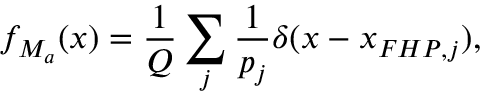Convert formula to latex. <formula><loc_0><loc_0><loc_500><loc_500>f _ { M _ { a } } ( x ) = \frac { 1 } { Q } \sum _ { j } \frac { 1 } { p _ { j } } \delta ( x - x _ { F H P , j } ) ,</formula> 